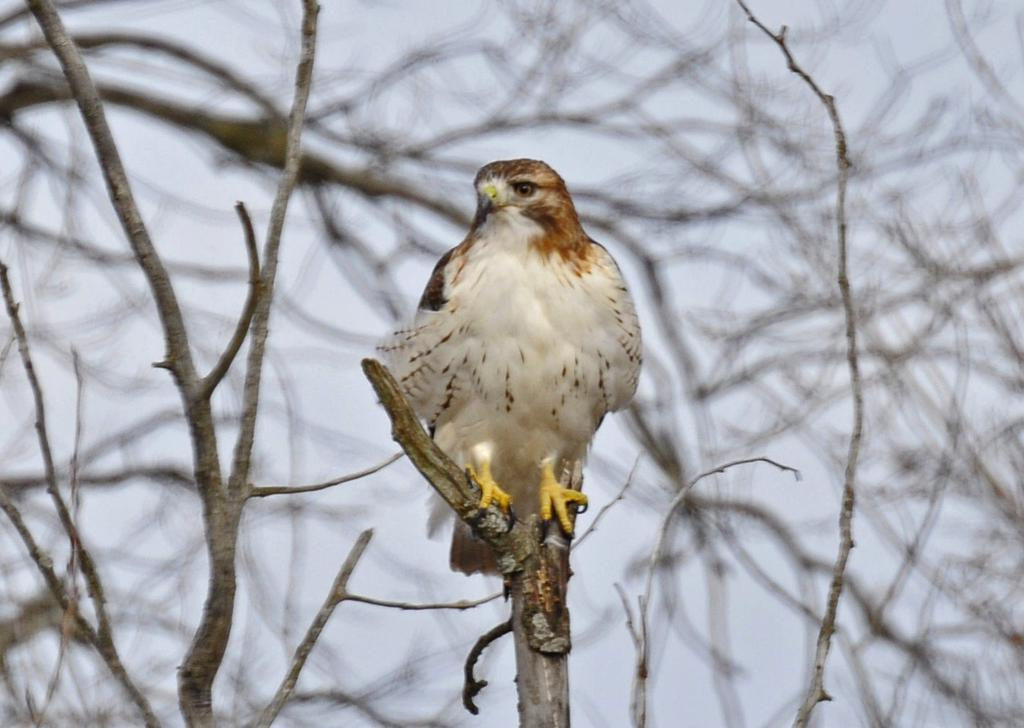What animal can be seen in the image? There is an eagle in the image. Where is the eagle located? The eagle is on a branch of a tree. What else can be seen in the background of the image? There are branches and the sky visible in the background of the image. How would you describe the quality of the image? The image is blurred. What type of quartz can be seen on the eagle's body in the image? There is no quartz present on the eagle's body in the image. Can you tell me how many wrens are perched on the branches in the image? There are no wrens present in the image; only an eagle can be seen. 